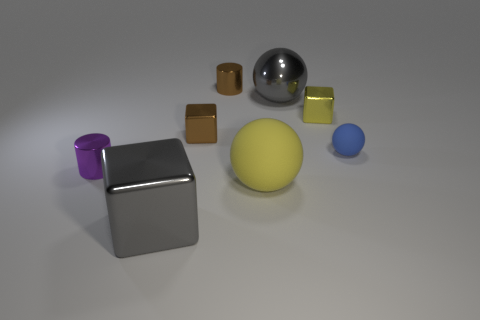Subtract all yellow cubes. How many cubes are left? 2 Add 1 large gray blocks. How many objects exist? 9 Subtract all cylinders. How many objects are left? 6 Subtract 1 blocks. How many blocks are left? 2 Subtract all brown cubes. How many cubes are left? 2 Subtract all gray cylinders. How many purple spheres are left? 0 Subtract all big objects. Subtract all shiny cylinders. How many objects are left? 3 Add 5 yellow metal cubes. How many yellow metal cubes are left? 6 Add 7 tiny yellow metallic things. How many tiny yellow metallic things exist? 8 Subtract 0 brown balls. How many objects are left? 8 